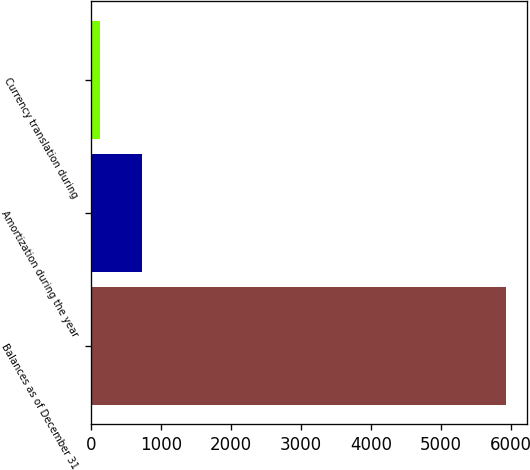<chart> <loc_0><loc_0><loc_500><loc_500><bar_chart><fcel>Balances as of December 31<fcel>Amortization during the year<fcel>Currency translation during<nl><fcel>5926.7<fcel>722.7<fcel>127<nl></chart> 